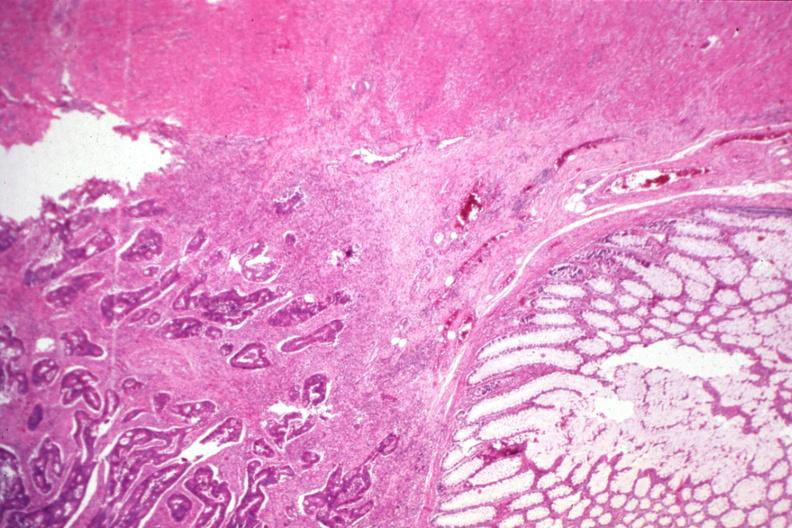what does this image show?
Answer the question using a single word or phrase. Typical infiltrating adenocarcinoma and normal mucosa 